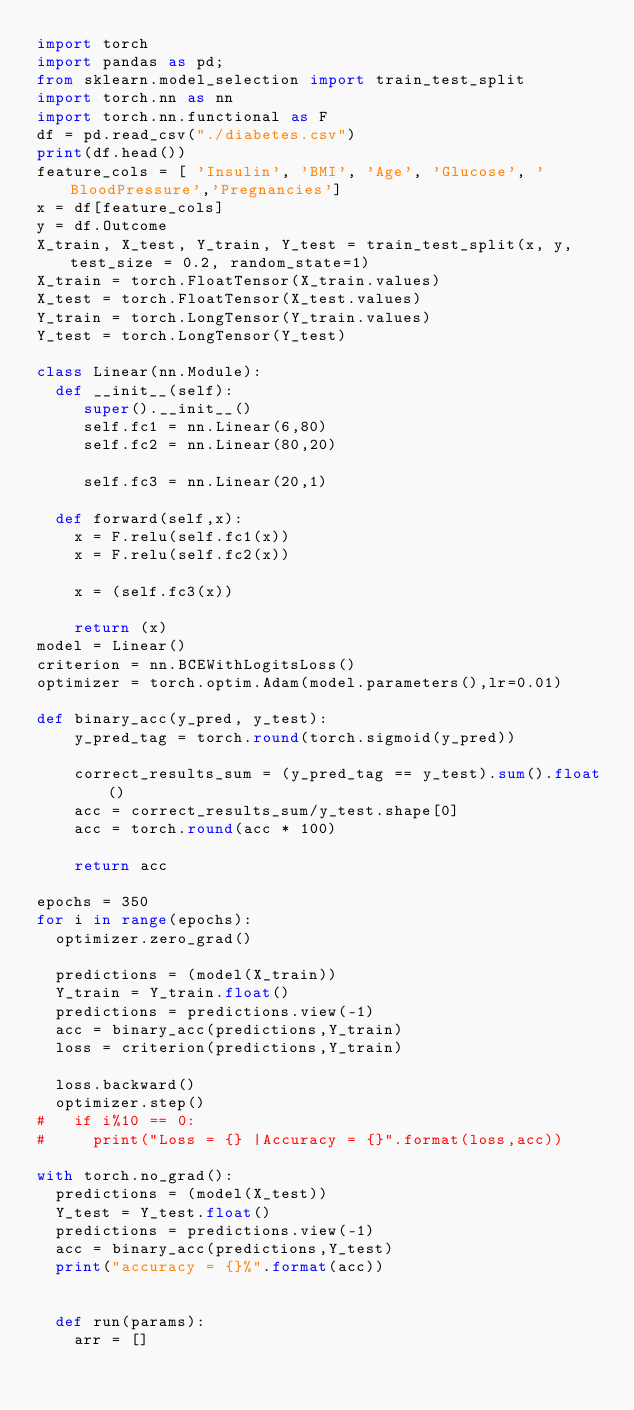<code> <loc_0><loc_0><loc_500><loc_500><_Python_>import torch
import pandas as pd;
from sklearn.model_selection import train_test_split
import torch.nn as nn
import torch.nn.functional as F
df = pd.read_csv("./diabetes.csv")
print(df.head())
feature_cols = [ 'Insulin', 'BMI', 'Age', 'Glucose', 'BloodPressure','Pregnancies']
x = df[feature_cols]
y = df.Outcome
X_train, X_test, Y_train, Y_test = train_test_split(x, y, test_size = 0.2, random_state=1)
X_train = torch.FloatTensor(X_train.values)
X_test = torch.FloatTensor(X_test.values)
Y_train = torch.LongTensor(Y_train.values)
Y_test = torch.LongTensor(Y_test)

class Linear(nn.Module):
  def __init__(self):
     super().__init__()
     self.fc1 = nn.Linear(6,80)
     self.fc2 = nn.Linear(80,20)
    
     self.fc3 = nn.Linear(20,1)
   
  def forward(self,x):
    x = F.relu(self.fc1(x))
    x = F.relu(self.fc2(x))
    
    x = (self.fc3(x))
    
    return (x)
model = Linear()
criterion = nn.BCEWithLogitsLoss()
optimizer = torch.optim.Adam(model.parameters(),lr=0.01)

def binary_acc(y_pred, y_test):
    y_pred_tag = torch.round(torch.sigmoid(y_pred))

    correct_results_sum = (y_pred_tag == y_test).sum().float()
    acc = correct_results_sum/y_test.shape[0]
    acc = torch.round(acc * 100)
    
    return acc

epochs = 350
for i in range(epochs):
  optimizer.zero_grad()
   
  predictions = (model(X_train))
  Y_train = Y_train.float()
  predictions = predictions.view(-1)
  acc = binary_acc(predictions,Y_train)
  loss = criterion(predictions,Y_train)
  
  loss.backward()
  optimizer.step()
#   if i%10 == 0:
#     print("Loss = {} |Accuracy = {}".format(loss,acc))

with torch.no_grad():
  predictions = (model(X_test))
  Y_test = Y_test.float()
  predictions = predictions.view(-1)
  acc = binary_acc(predictions,Y_test)
  print("accuracy = {}%".format(acc))


  def run(params):
    arr = []</code> 